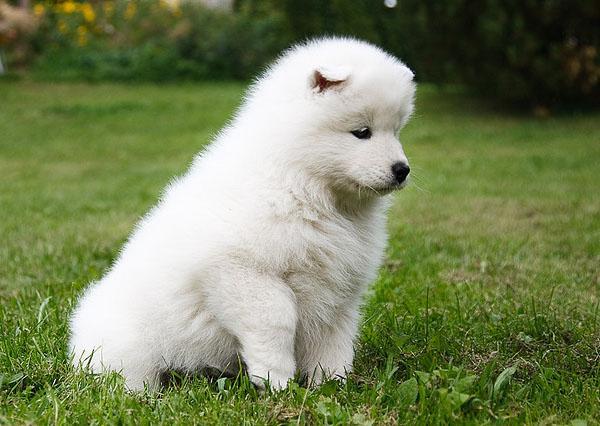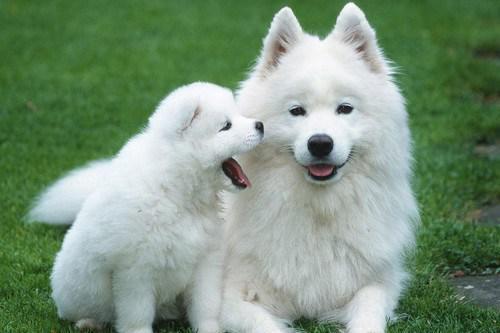The first image is the image on the left, the second image is the image on the right. Given the left and right images, does the statement "There are more dogs in the right image than in the left." hold true? Answer yes or no. Yes. 